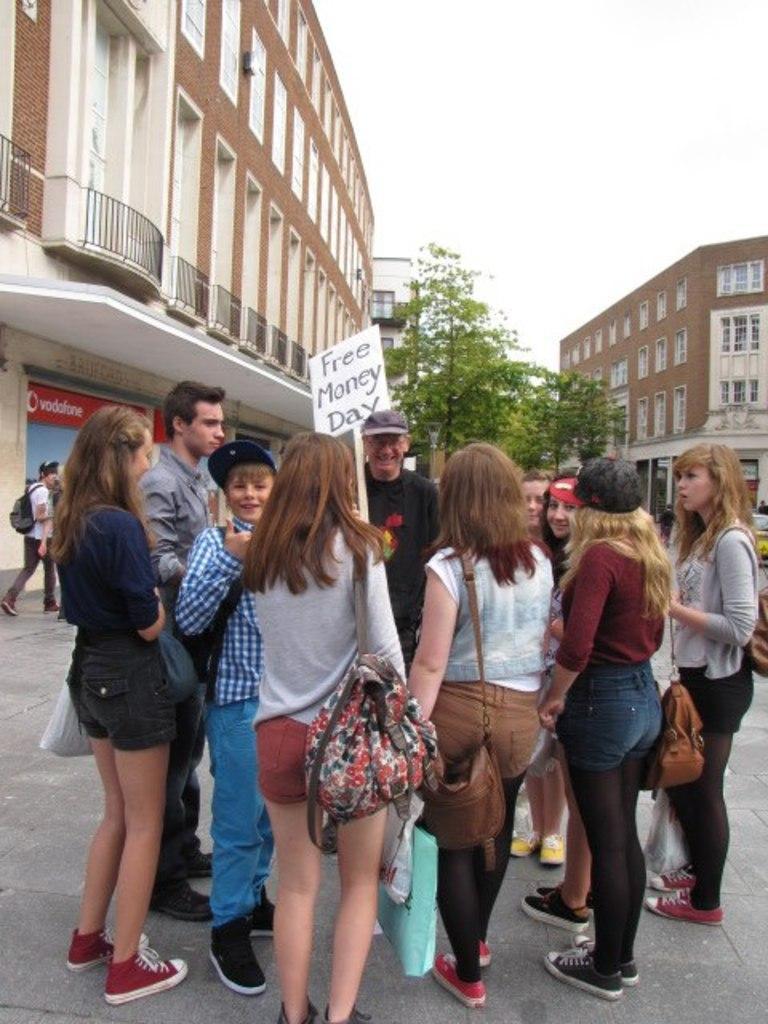In one or two sentences, can you explain what this image depicts? In this picture I can see few people are standing and few people wearing bags and a man holding a placard with some text and I can see a human wearing a backpack and walking. I can see buildings, trees and a board with some text and I can see cloudy sky and looks like a car in the back. 